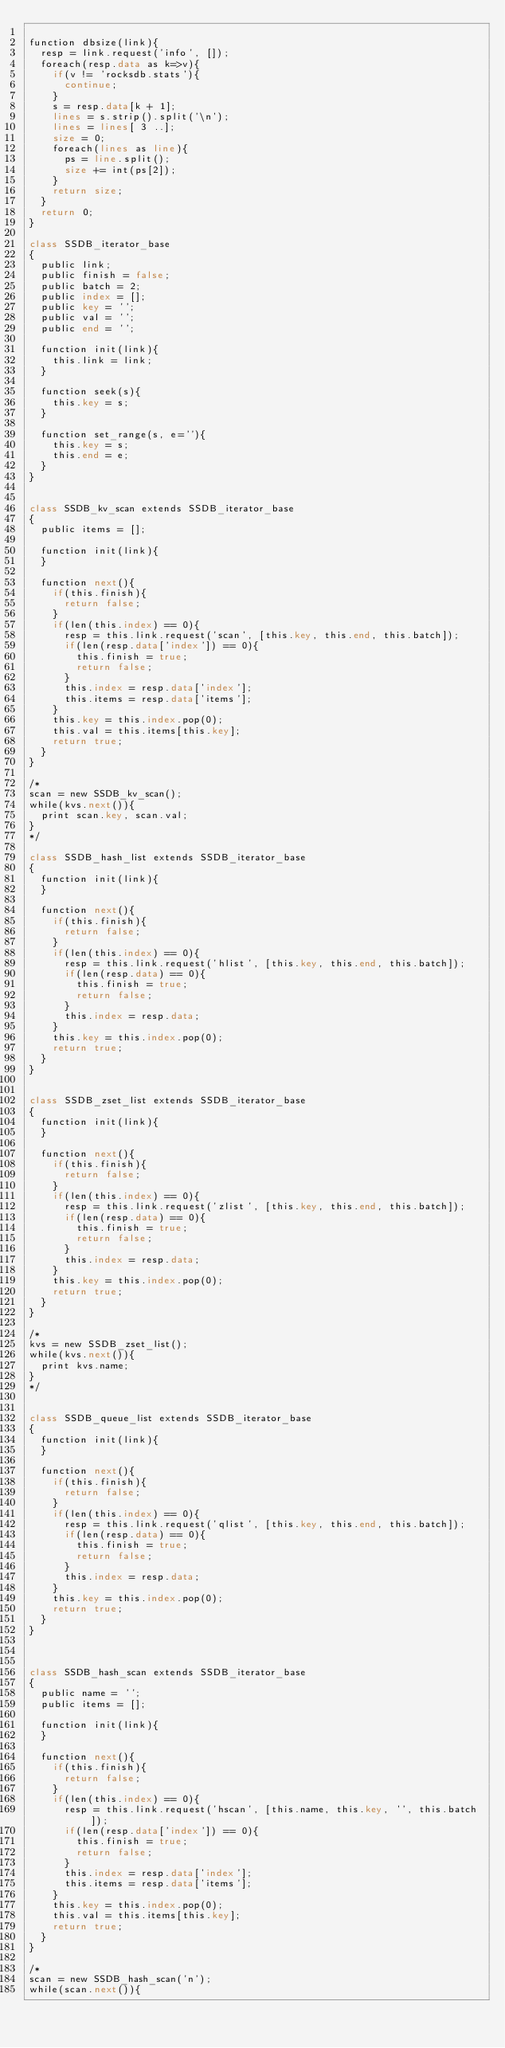Convert code to text. <code><loc_0><loc_0><loc_500><loc_500><_COBOL_>
function dbsize(link){
	resp = link.request('info', []);
	foreach(resp.data as k=>v){
		if(v != 'rocksdb.stats'){
			continue;
		}
		s = resp.data[k + 1];
		lines = s.strip().split('\n');
		lines = lines[ 3 ..];
		size = 0;
		foreach(lines as line){
			ps = line.split();
			size += int(ps[2]);
		}
		return size;
	}
	return 0;
}

class SSDB_iterator_base
{
	public link;
	public finish = false;
	public batch = 2;
	public index = [];
	public key = '';
	public val = '';
	public end = '';
	
	function init(link){
		this.link = link;
	}
	
	function seek(s){
		this.key = s;
	}
	
	function set_range(s, e=''){
		this.key = s;
		this.end = e;
	}
}


class SSDB_kv_scan extends SSDB_iterator_base
{
	public items = [];

	function init(link){
	}
	
	function next(){
		if(this.finish){
			return false;
		}
		if(len(this.index) == 0){
			resp = this.link.request('scan', [this.key, this.end, this.batch]);
			if(len(resp.data['index']) == 0){
				this.finish = true;
				return false;
			}
			this.index = resp.data['index'];
			this.items = resp.data['items'];
		}
		this.key = this.index.pop(0);
		this.val = this.items[this.key];
		return true;
	}
}

/*
scan = new SSDB_kv_scan();
while(kvs.next()){
	print scan.key, scan.val;
}
*/

class SSDB_hash_list extends SSDB_iterator_base
{
	function init(link){
	}
	
	function next(){
		if(this.finish){
			return false;
		}
		if(len(this.index) == 0){
			resp = this.link.request('hlist', [this.key, this.end, this.batch]);
			if(len(resp.data) == 0){
				this.finish = true;
				return false;
			}
			this.index = resp.data;
		}
		this.key = this.index.pop(0);
		return true;
	}
}


class SSDB_zset_list extends SSDB_iterator_base
{
	function init(link){
	}
	
	function next(){
		if(this.finish){
			return false;
		}
		if(len(this.index) == 0){
			resp = this.link.request('zlist', [this.key, this.end, this.batch]);
			if(len(resp.data) == 0){
				this.finish = true;
				return false;
			}
			this.index = resp.data;
		}
		this.key = this.index.pop(0);
		return true;
	}
}

/*
kvs = new SSDB_zset_list();
while(kvs.next()){
	print kvs.name;
}
*/


class SSDB_queue_list extends SSDB_iterator_base
{
	function init(link){
	}
	
	function next(){
		if(this.finish){
			return false;
		}
		if(len(this.index) == 0){
			resp = this.link.request('qlist', [this.key, this.end, this.batch]);
			if(len(resp.data) == 0){
				this.finish = true;
				return false;
			}
			this.index = resp.data;
		}
		this.key = this.index.pop(0);
		return true;
	}
}



class SSDB_hash_scan extends SSDB_iterator_base
{
	public name = '';
	public items = [];
	
	function init(link){
	}
	
	function next(){
		if(this.finish){
			return false;
		}
		if(len(this.index) == 0){
			resp = this.link.request('hscan', [this.name, this.key, '', this.batch]);
			if(len(resp.data['index']) == 0){
				this.finish = true;
				return false;
			}
			this.index = resp.data['index'];
			this.items = resp.data['items'];
		}
		this.key = this.index.pop(0);
		this.val = this.items[this.key];
		return true;
	}
}

/*
scan = new SSDB_hash_scan('n');
while(scan.next()){</code> 